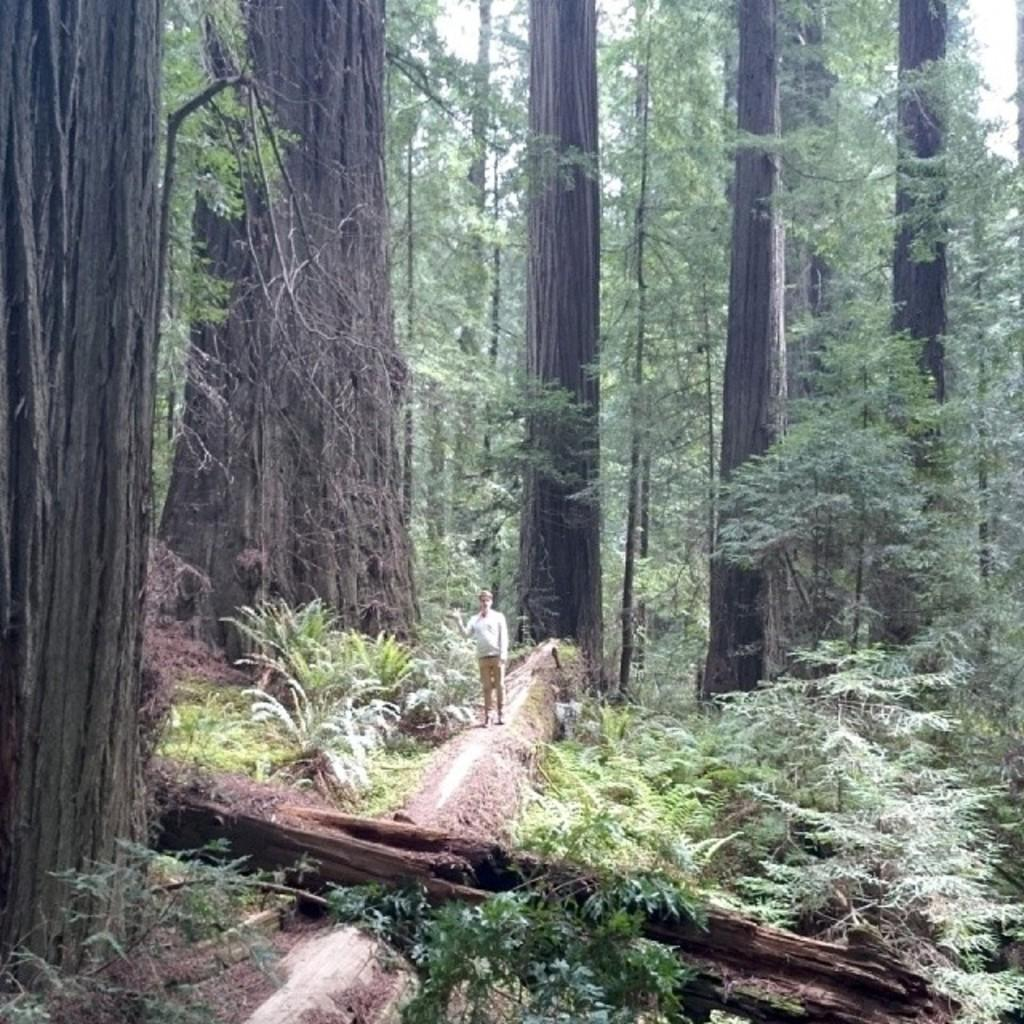What is the main subject of the image? There is a person standing in the center of the image. What can be seen in the background of the image? There are many trees in the background of the image. Where is the throne located in the image? There is no throne present in the image. What type of patch can be seen on the person's clothing in the image? There is no patch visible on the person's clothing in the image. 